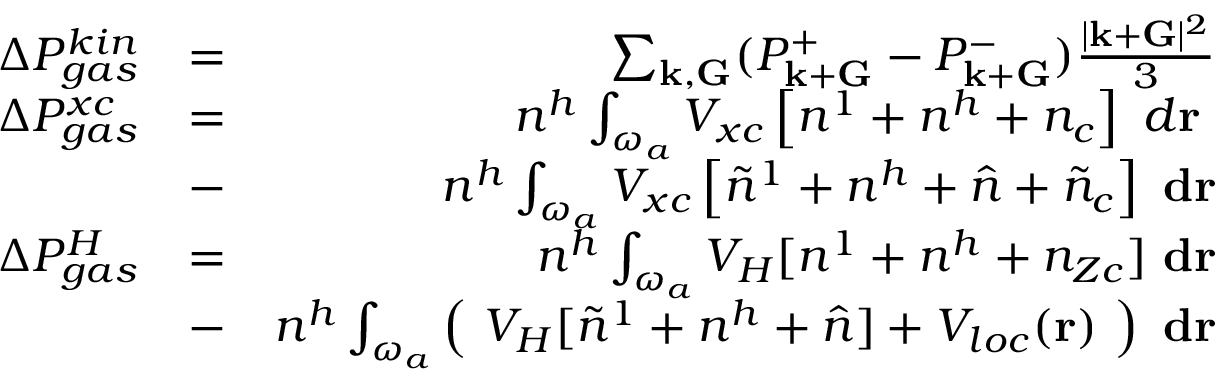<formula> <loc_0><loc_0><loc_500><loc_500>\begin{array} { r l r } { \Delta P _ { g a s } ^ { k i n } } & { = } & { \sum _ { { k } , { G } } ( P _ { { k } + { G } } ^ { + } - P _ { { k } + { G } } ^ { - } ) \frac { | { k } + { G } | ^ { 2 } } { 3 } } \\ { \Delta P _ { g a s } ^ { x c } } & { = } & { n ^ { h } \int _ { \omega _ { a } } V _ { x c } \left [ n ^ { 1 } + n ^ { h } + n _ { c } \right ] d { r } } \\ & { - } & { n ^ { h } \int _ { \omega _ { a } } V _ { x c } \left [ \tilde { n } ^ { 1 } + n ^ { h } + \hat { n } + \tilde { n } _ { c } \right ] { d r } } \\ { \Delta P _ { g a s } ^ { H } } & { = } & { n ^ { h } \int _ { \omega _ { a } } V _ { H } [ n ^ { 1 } + n ^ { h } + n _ { Z c } ] { d r } } \\ & { - } & { n ^ { h } \int _ { \omega _ { a } } \left ( V _ { H } [ \tilde { n } ^ { 1 } + n ^ { h } + \hat { n } ] + V _ { l o c } ( { r } ) \right ) { d r } } \end{array}</formula> 